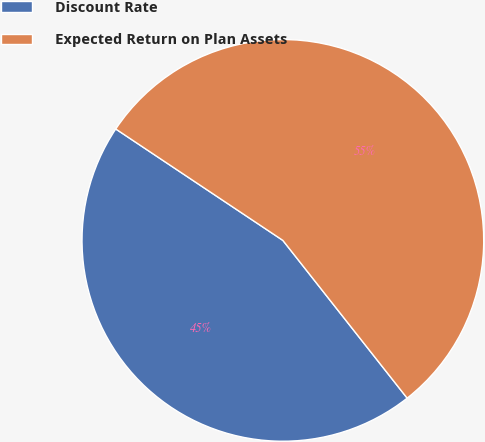<chart> <loc_0><loc_0><loc_500><loc_500><pie_chart><fcel>Discount Rate<fcel>Expected Return on Plan Assets<nl><fcel>44.98%<fcel>55.02%<nl></chart> 